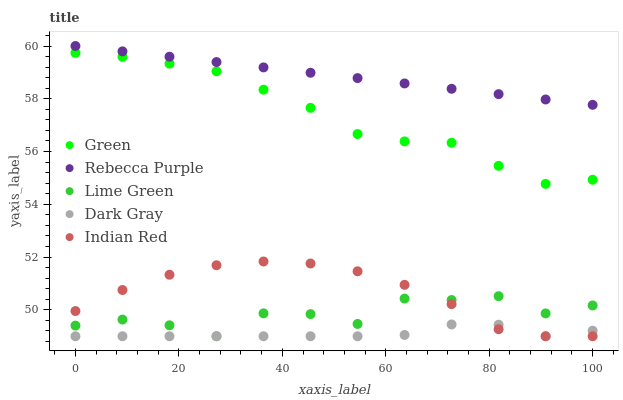Does Dark Gray have the minimum area under the curve?
Answer yes or no. Yes. Does Rebecca Purple have the maximum area under the curve?
Answer yes or no. Yes. Does Lime Green have the minimum area under the curve?
Answer yes or no. No. Does Lime Green have the maximum area under the curve?
Answer yes or no. No. Is Rebecca Purple the smoothest?
Answer yes or no. Yes. Is Lime Green the roughest?
Answer yes or no. Yes. Is Green the smoothest?
Answer yes or no. No. Is Green the roughest?
Answer yes or no. No. Does Dark Gray have the lowest value?
Answer yes or no. Yes. Does Green have the lowest value?
Answer yes or no. No. Does Rebecca Purple have the highest value?
Answer yes or no. Yes. Does Lime Green have the highest value?
Answer yes or no. No. Is Indian Red less than Rebecca Purple?
Answer yes or no. Yes. Is Green greater than Dark Gray?
Answer yes or no. Yes. Does Dark Gray intersect Lime Green?
Answer yes or no. Yes. Is Dark Gray less than Lime Green?
Answer yes or no. No. Is Dark Gray greater than Lime Green?
Answer yes or no. No. Does Indian Red intersect Rebecca Purple?
Answer yes or no. No. 